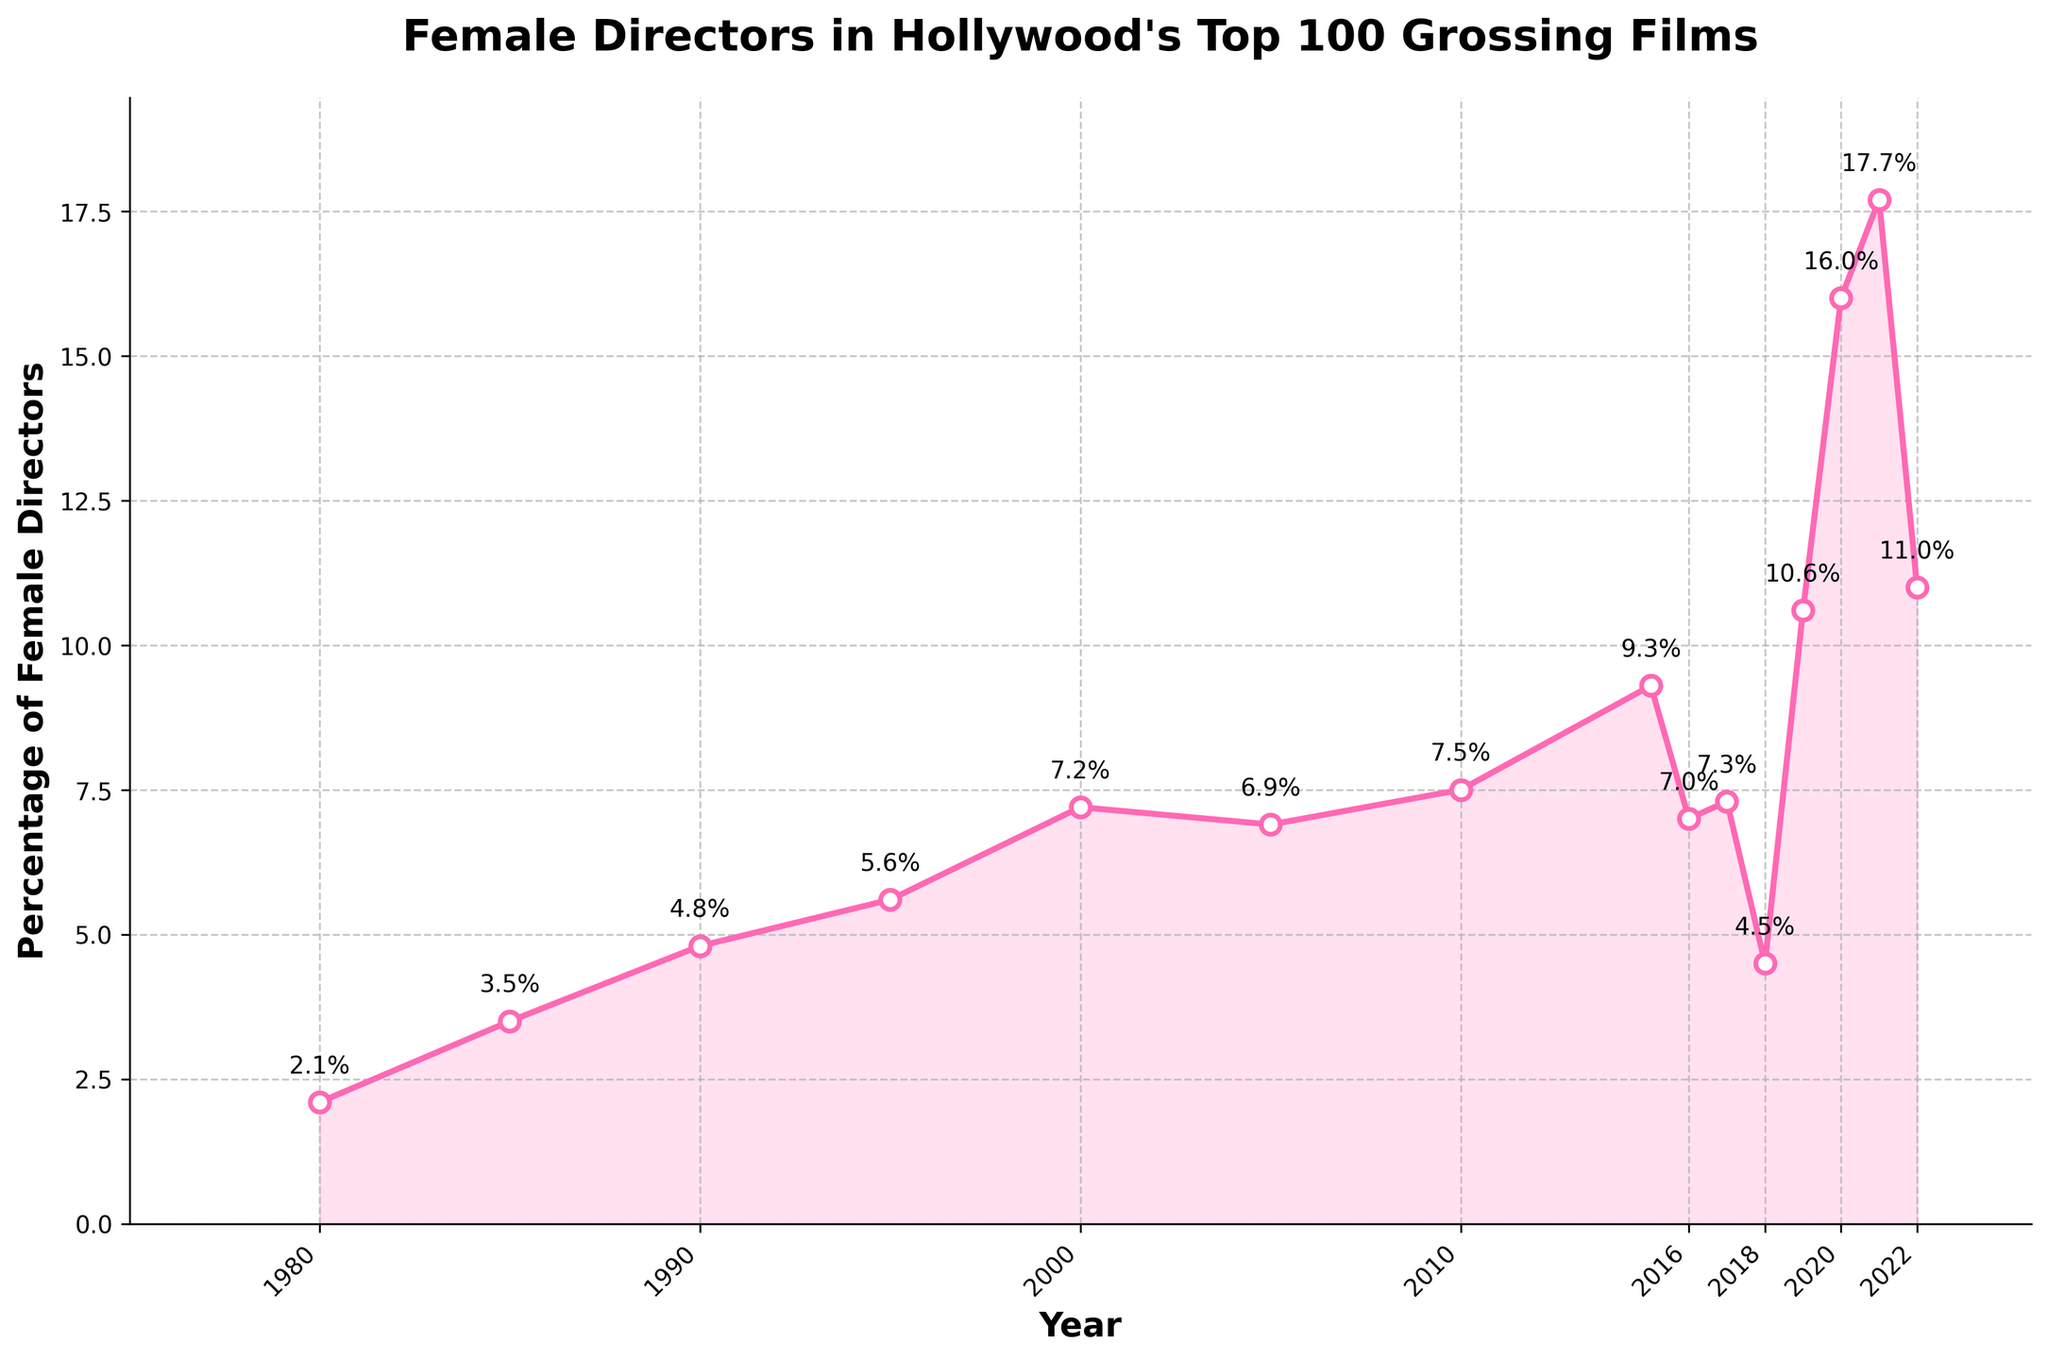What is the percentage increase in female directors from 1980 to 2020? First, identify the percentages for 1980 and 2020, which are 2.1% and 16.0%, respectively. Then, calculate the difference: 16.0% - 2.1% = 13.9%. Therefore, the percentage increase is 13.9%.
Answer: 13.9% Between which years did the percentage of female directors exhibit the most significant jump? Observe the plot and identify the two consecutive years showing the largest increase. The most significant jump is between 2019 (10.6%) and 2020 (16.0%), giving an increase of 5.4%.
Answer: 2019 and 2020 Which year saw the lowest percentage of female directors? Look at the plot and identify the year where the line hits the lowest point. In 1980, the percentage was the lowest at 2.1%.
Answer: 1980 Was there a general upward or downward trend in the percentage of female directors from 1980 to 2022? Observe the overall direction of the line from start to end. The line generally trends upward from 1980 to 2022, despite some fluctuations.
Answer: Upward What is the average percentage of female directors from 2000 to 2010? First, list the percentages for the years 2000, 2005, and 2010, which are 7.2%, 6.9%, and 7.5%, respectively. Then, calculate the average: (7.2 + 6.9 + 7.5) / 3 = 7.2%.
Answer: 7.2% How does the percentage of female directors in 2022 compare to that in 2021? Identify the percentages for 2021 (17.7%) and 2022 (11.0%). Then, compare the values: 2021 had a higher percentage than 2022.
Answer: 2021 higher What was the percentage change between 2018 and 2019? Identify the percentages for 2018 and 2019, which are 4.5% and 10.6%, respectively. Calculate the difference: 10.6% - 4.5% = 6.1%. Then, express this as a percentage change: (6.1 / 4.5) * 100 ≈ 135.6%.
Answer: 135.6% Which year had the highest percentage of female directors? Look at the plot and identify the peak value. In 2021, the percentage was highest at 17.7%.
Answer: 2021 Between which two consecutive years did the percentage decrease most sharply? Evaluate the differences between percentages for consecutive years. The largest decrease is between 2021 (17.7%) and 2022 (11.0%), a drop of 6.7%.
Answer: 2021 and 2022 